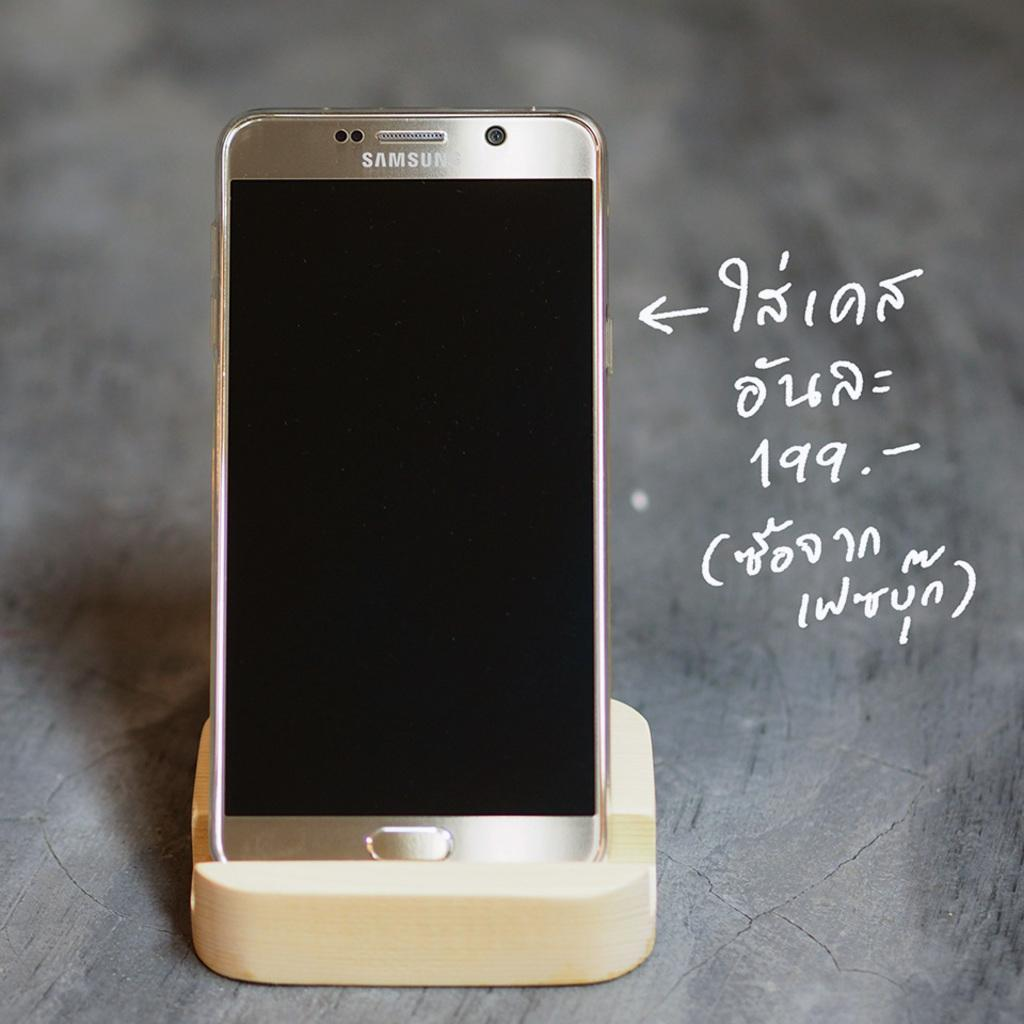<image>
Relay a brief, clear account of the picture shown. a Samsung cell phone with some foreign language annotation on the right 